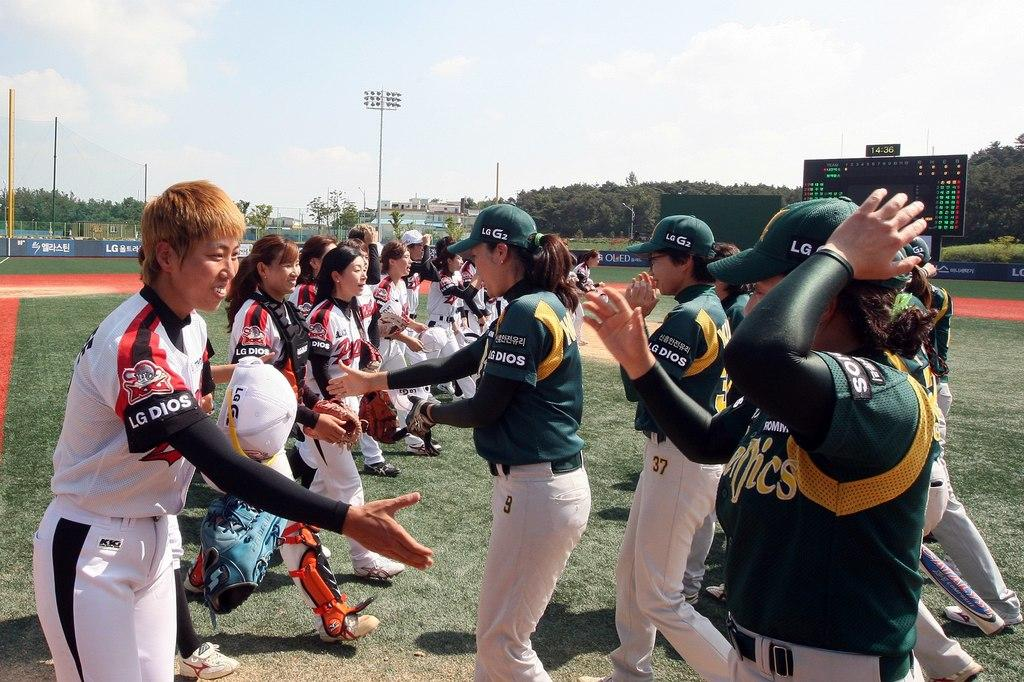<image>
Give a short and clear explanation of the subsequent image. A player with LG Dios on their sleeve reaches out to shake and opponent's hand. 